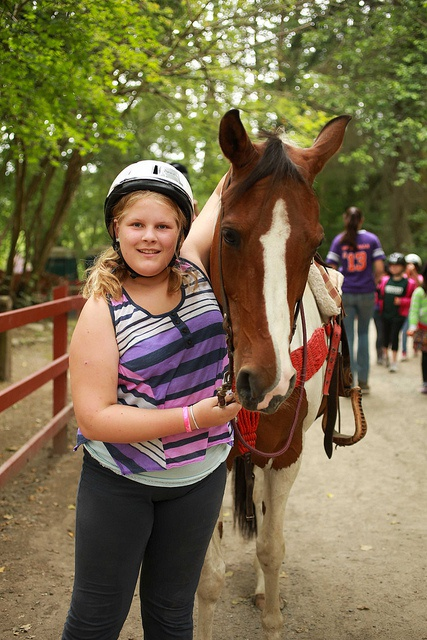Describe the objects in this image and their specific colors. I can see people in black, tan, and brown tones, horse in black, maroon, and tan tones, people in black, purple, gray, and navy tones, people in black, maroon, brown, and darkgray tones, and people in black, maroon, and olive tones in this image. 